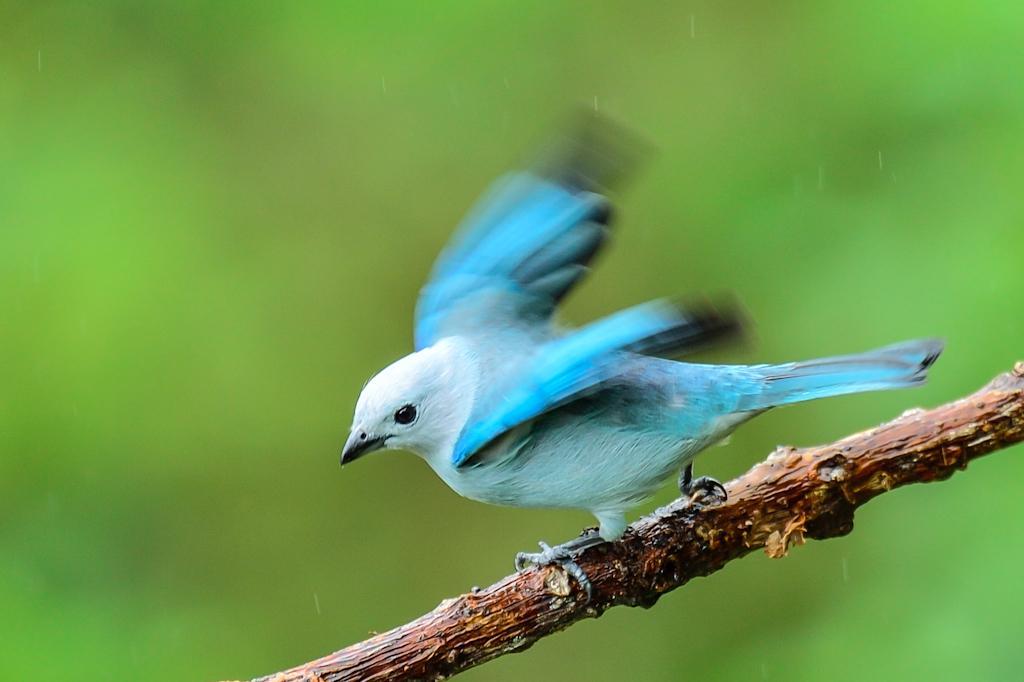How would you summarize this image in a sentence or two? In this picture there is a bird in the center of the image, on a stem. 